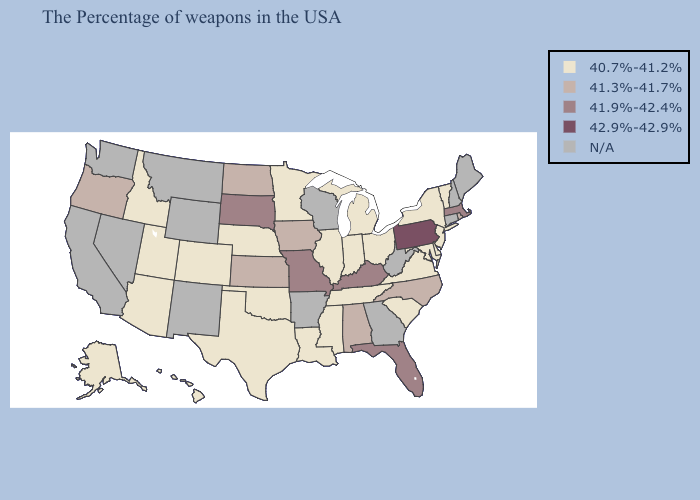What is the highest value in the South ?
Be succinct. 41.9%-42.4%. Does Utah have the highest value in the USA?
Answer briefly. No. What is the value of Indiana?
Write a very short answer. 40.7%-41.2%. What is the lowest value in the MidWest?
Keep it brief. 40.7%-41.2%. Name the states that have a value in the range 41.3%-41.7%?
Concise answer only. Rhode Island, North Carolina, Alabama, Iowa, Kansas, North Dakota, Oregon. Is the legend a continuous bar?
Short answer required. No. What is the value of Colorado?
Quick response, please. 40.7%-41.2%. Name the states that have a value in the range 40.7%-41.2%?
Answer briefly. Vermont, New York, New Jersey, Delaware, Maryland, Virginia, South Carolina, Ohio, Michigan, Indiana, Tennessee, Illinois, Mississippi, Louisiana, Minnesota, Nebraska, Oklahoma, Texas, Colorado, Utah, Arizona, Idaho, Alaska, Hawaii. Does Rhode Island have the lowest value in the USA?
Give a very brief answer. No. Name the states that have a value in the range N/A?
Answer briefly. Maine, New Hampshire, Connecticut, West Virginia, Georgia, Wisconsin, Arkansas, Wyoming, New Mexico, Montana, Nevada, California, Washington. Which states have the lowest value in the USA?
Keep it brief. Vermont, New York, New Jersey, Delaware, Maryland, Virginia, South Carolina, Ohio, Michigan, Indiana, Tennessee, Illinois, Mississippi, Louisiana, Minnesota, Nebraska, Oklahoma, Texas, Colorado, Utah, Arizona, Idaho, Alaska, Hawaii. What is the value of Nebraska?
Write a very short answer. 40.7%-41.2%. What is the highest value in the USA?
Be succinct. 42.9%-42.9%. Name the states that have a value in the range N/A?
Quick response, please. Maine, New Hampshire, Connecticut, West Virginia, Georgia, Wisconsin, Arkansas, Wyoming, New Mexico, Montana, Nevada, California, Washington. 